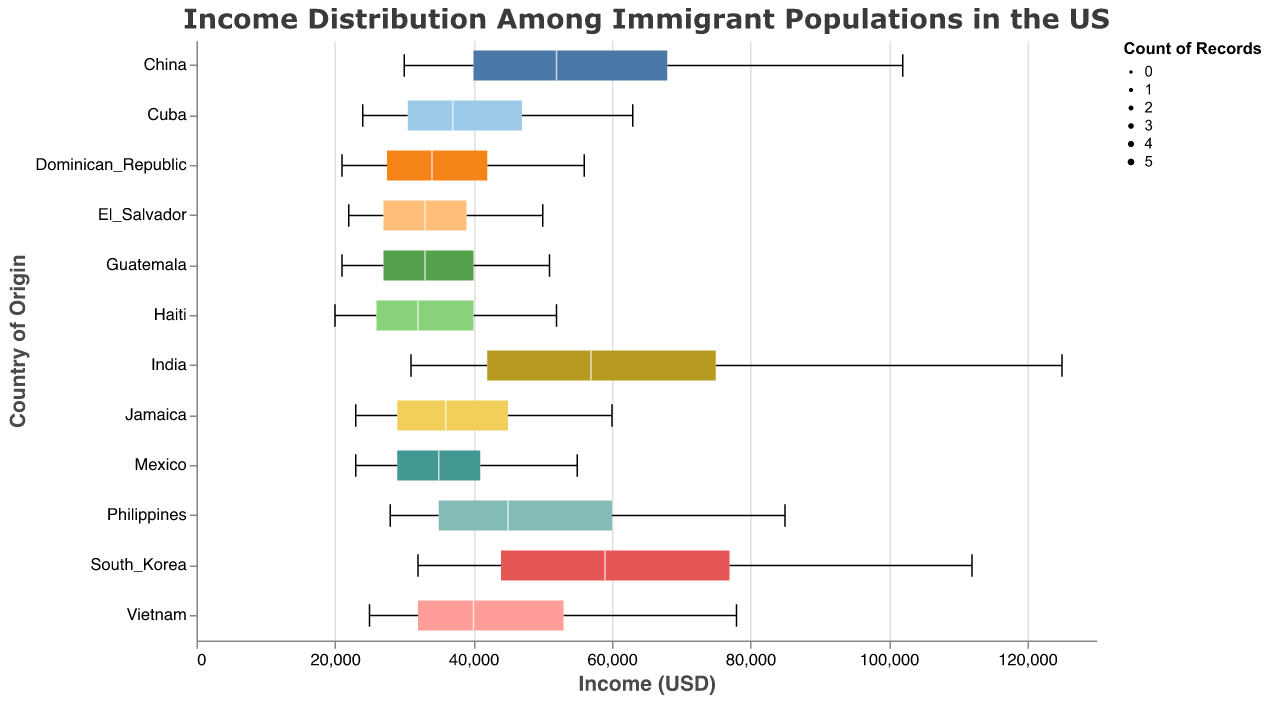What is the median income for immigrants from China? To determine the median income for immigrants from China, look at the interquartile range (IQR) in the China box plot. The middle line inside the box represents the median value, which is 52,000.
Answer: 52,000 What country of origin has the highest upper middle income? To find the country with the highest upper middle income, examine the top of the whisker. India has the highest value at 75,000.
Answer: India Compare the low income for immigrants from India and Haiti. Which is higher and by how much? To compare the low income values, find India's and Haiti's low income figures. India has a low income of 31,000 and Haiti has 20,000. The difference is 31,000 - 20,000 = 11,000.
Answer: India by 11,000 Which group appears to have the widest income range from low income to high income? To find the group with the widest range, look at the span from the bottom to the top of each box plot. India shows the largest spread from 31,000 to 125,000.
Answer: India What is the lower middle income for immigrants from the Philippines? The lower middle income is found at the bottom of the box in the box plot for the Philippines, which is 35,000.
Answer: 35,000 Which two countries have the closest median incomes? By comparing the median lines (middle lines within the boxes) of the box plots, Mexico and the Dominican Republic have similar median incomes around 35,000 and 34,000 respectively.
Answer: Mexico and Dominican Republic Determine the difference in high income values between Mexico and South Korea. To find the difference, identify the high-income values for both countries. Mexico has 55,000 and South Korea has 112,000. Therefore, the difference is 112,000 - 55,000 = 57,000.
Answer: 57,000 Which country has a low income value under 22,000? By examining the box plots' lower whiskers, Haiti and Guatemala both have low-income values of 20,000 and 21,000 respectively.
Answer: Haiti and Guatemala 